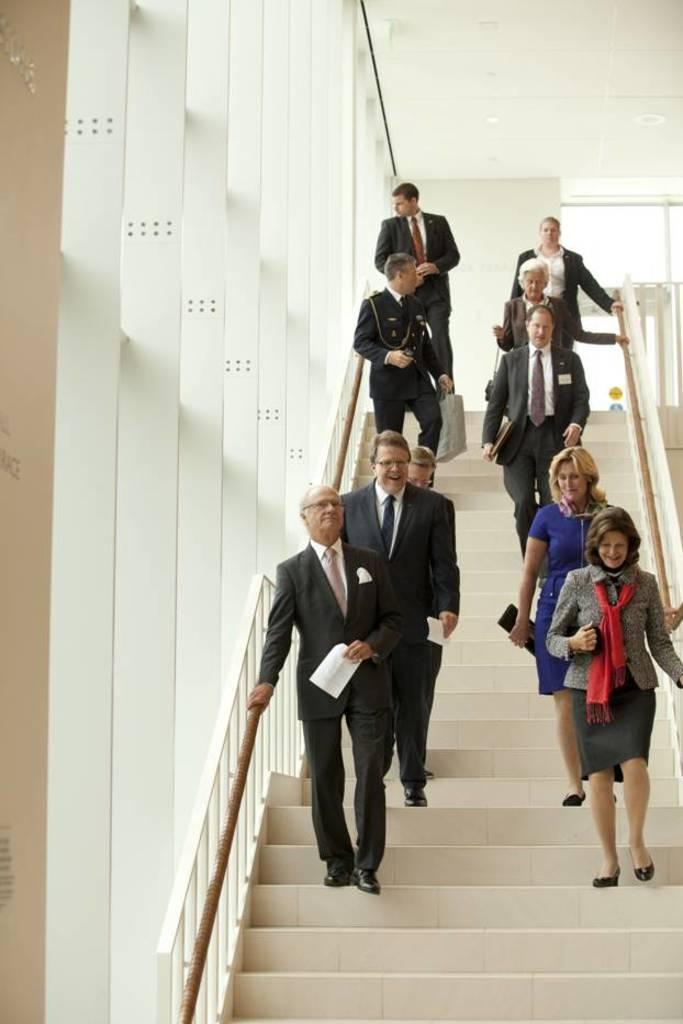How many people are in the image? There are persons in the image. What are the persons doing in the image? The persons are on stairs. What are the persons wearing in the image? The persons are wearing clothes. What can be seen in the top right of the image? There is a ceiling visible in the top right of the image. What type of jeans is the kitten wearing in the image? There is no kitten present in the image, and therefore no one is wearing jeans. What noise can be heard coming from the persons in the image? The image is silent, and no noise can be heard. 